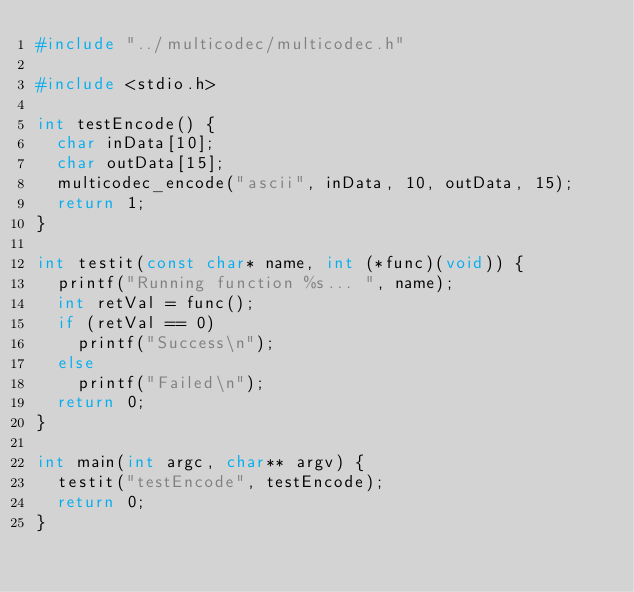Convert code to text. <code><loc_0><loc_0><loc_500><loc_500><_C_>#include "../multicodec/multicodec.h"

#include <stdio.h>

int testEncode() {
	char inData[10];
	char outData[15];
	multicodec_encode("ascii", inData, 10, outData, 15);
	return 1;
}

int testit(const char* name, int (*func)(void)) {
	printf("Running function %s... ", name);
	int retVal = func();
	if (retVal == 0)
		printf("Success\n");
	else
		printf("Failed\n");
	return 0;
}

int main(int argc, char** argv) {
	testit("testEncode", testEncode);
	return 0;
}
</code> 